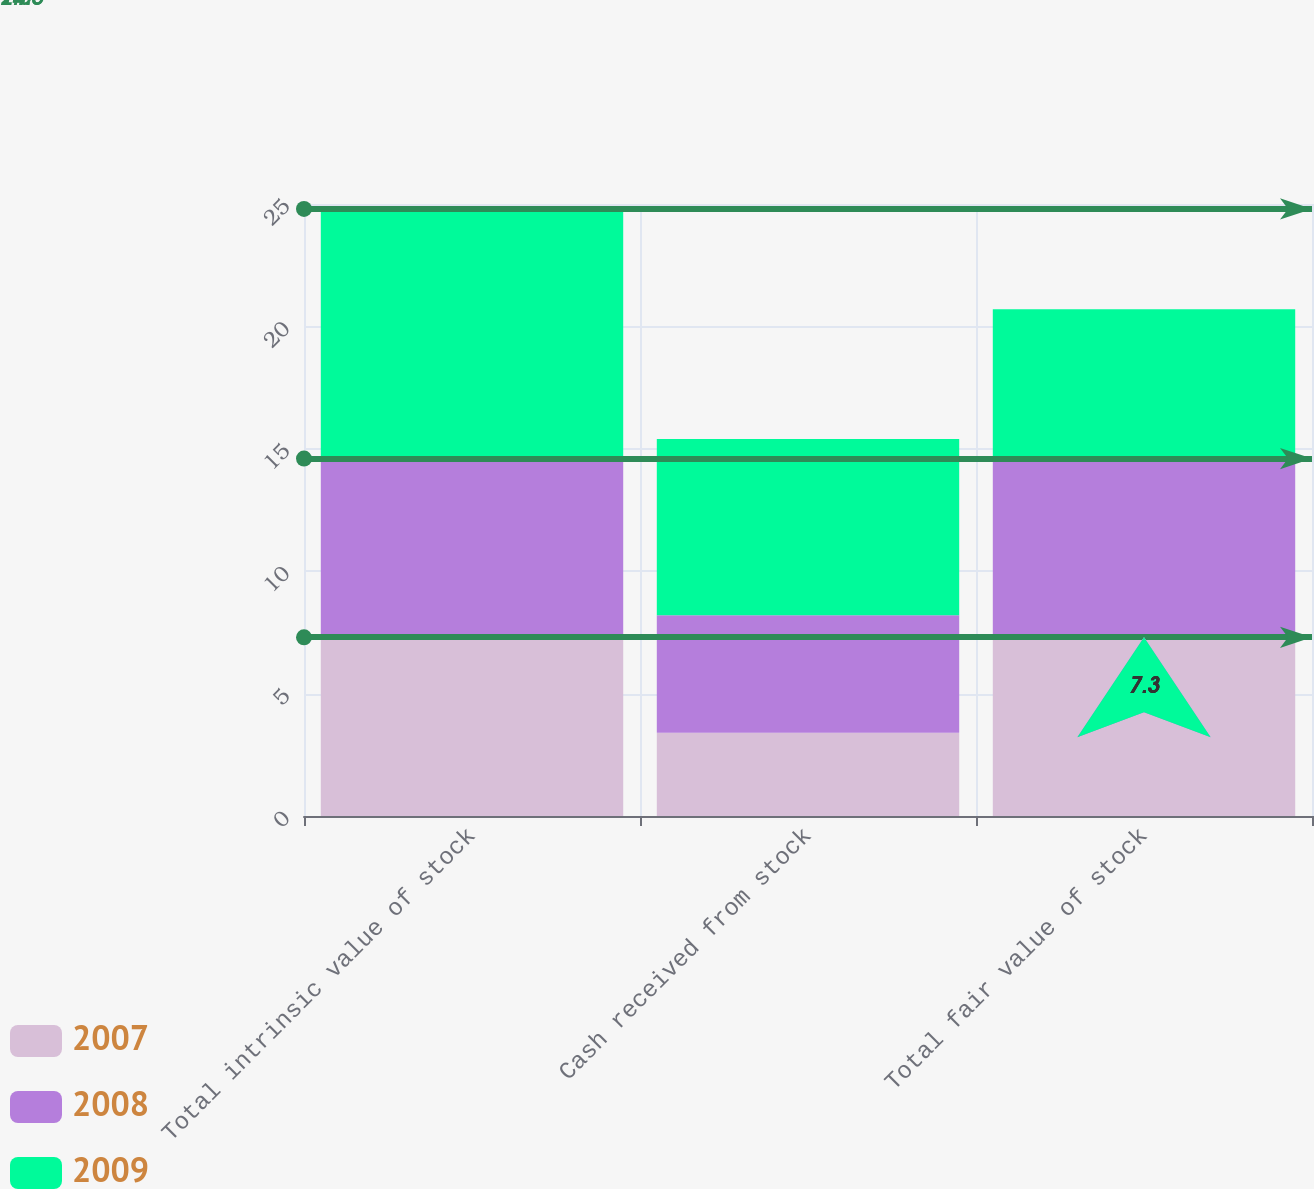<chart> <loc_0><loc_0><loc_500><loc_500><stacked_bar_chart><ecel><fcel>Total intrinsic value of stock<fcel>Cash received from stock<fcel>Total fair value of stock<nl><fcel>2007<fcel>7.2<fcel>3.4<fcel>7.3<nl><fcel>2008<fcel>7.4<fcel>4.8<fcel>7.2<nl><fcel>2009<fcel>10.2<fcel>7.2<fcel>6.2<nl></chart> 